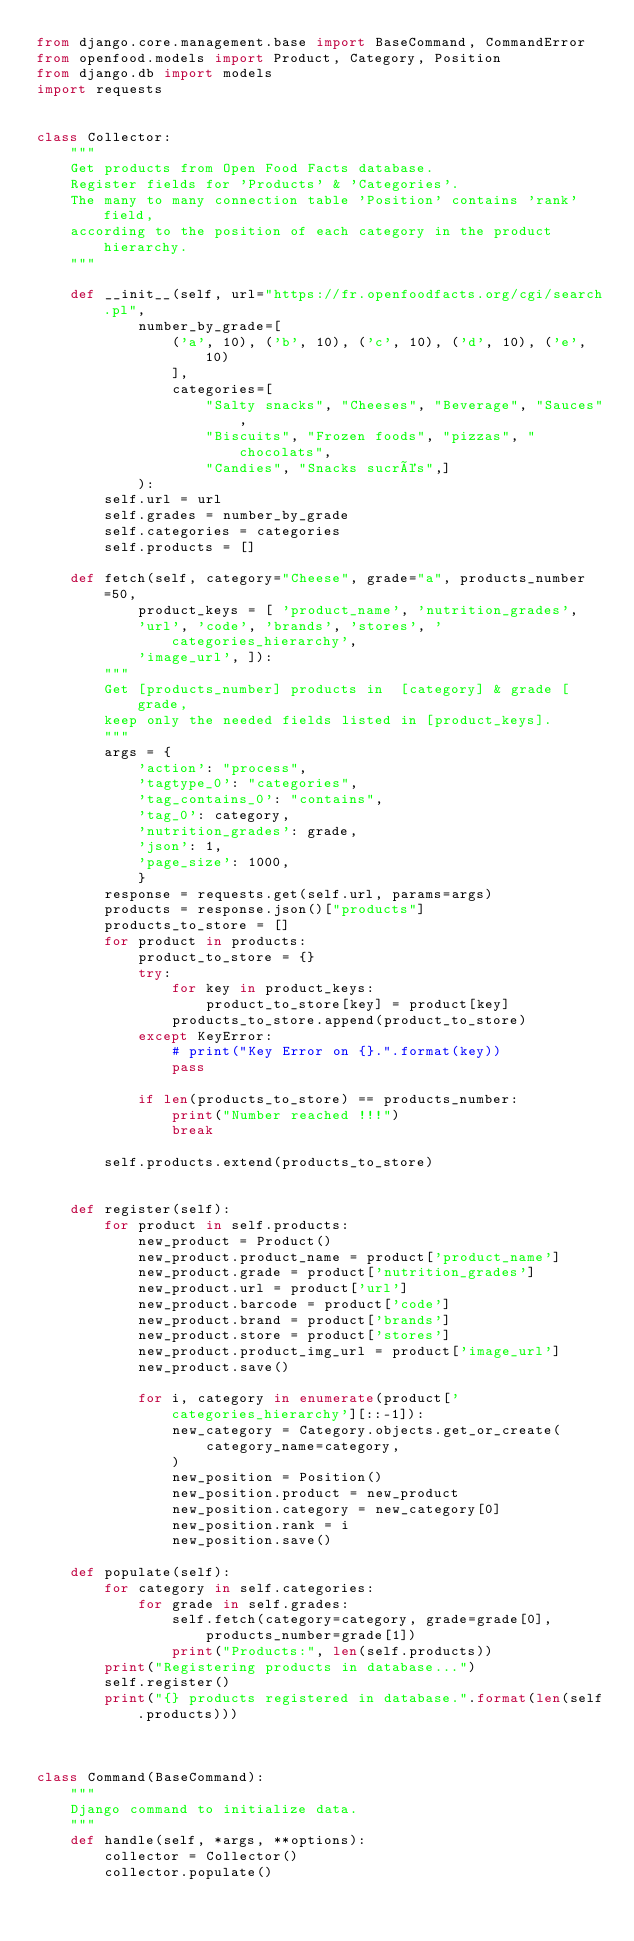Convert code to text. <code><loc_0><loc_0><loc_500><loc_500><_Python_>from django.core.management.base import BaseCommand, CommandError
from openfood.models import Product, Category, Position
from django.db import models
import requests


class Collector:
    """
    Get products from Open Food Facts database.
    Register fields for 'Products' & 'Categories'.
    The many to many connection table 'Position' contains 'rank' field,
    according to the position of each category in the product hierarchy.
    """

    def __init__(self, url="https://fr.openfoodfacts.org/cgi/search.pl",
            number_by_grade=[
                ('a', 10), ('b', 10), ('c', 10), ('d', 10), ('e', 10)
                ],
                categories=[
                    "Salty snacks", "Cheeses", "Beverage", "Sauces",
                    "Biscuits", "Frozen foods", "pizzas", "chocolats",
                    "Candies", "Snacks sucrés",]
            ):
        self.url = url
        self.grades = number_by_grade
        self.categories = categories
        self.products = []

    def fetch(self, category="Cheese", grade="a", products_number=50,
            product_keys = [ 'product_name', 'nutrition_grades',
            'url', 'code', 'brands', 'stores', 'categories_hierarchy',
            'image_url', ]):
        """
        Get [products_number] products in  [category] & grade [grade,
        keep only the needed fields listed in [product_keys].
        """
        args = {
            'action': "process",
            'tagtype_0': "categories",
            'tag_contains_0': "contains",
            'tag_0': category,
            'nutrition_grades': grade,
            'json': 1,
            'page_size': 1000,
            }
        response = requests.get(self.url, params=args)
        products = response.json()["products"]
        products_to_store = []
        for product in products:
            product_to_store = {}
            try:
                for key in product_keys:
                    product_to_store[key] = product[key]
                products_to_store.append(product_to_store)
            except KeyError:
                # print("Key Error on {}.".format(key))
                pass

            if len(products_to_store) == products_number:
                print("Number reached !!!")
                break

        self.products.extend(products_to_store)


    def register(self):
        for product in self.products:
            new_product = Product()
            new_product.product_name = product['product_name']
            new_product.grade = product['nutrition_grades']
            new_product.url = product['url']
            new_product.barcode = product['code']
            new_product.brand = product['brands']
            new_product.store = product['stores']
            new_product.product_img_url = product['image_url']
            new_product.save()

            for i, category in enumerate(product['categories_hierarchy'][::-1]):
                new_category = Category.objects.get_or_create(
                    category_name=category,
                )
                new_position = Position()
                new_position.product = new_product
                new_position.category = new_category[0]
                new_position.rank = i
                new_position.save()

    def populate(self):
        for category in self.categories:
            for grade in self.grades:
                self.fetch(category=category, grade=grade[0],
                    products_number=grade[1])
                print("Products:", len(self.products))
        print("Registering products in database...")
        self.register()
        print("{} products registered in database.".format(len(self.products)))



class Command(BaseCommand):
    """
    Django command to initialize data.
    """
    def handle(self, *args, **options):
        collector = Collector()
        collector.populate()</code> 